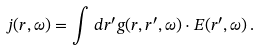<formula> <loc_0><loc_0><loc_500><loc_500>j ( r , \omega ) = \int \, d r ^ { \prime } g ( r , r ^ { \prime } , \omega ) \cdot E ( r ^ { \prime } , \omega ) \, .</formula> 